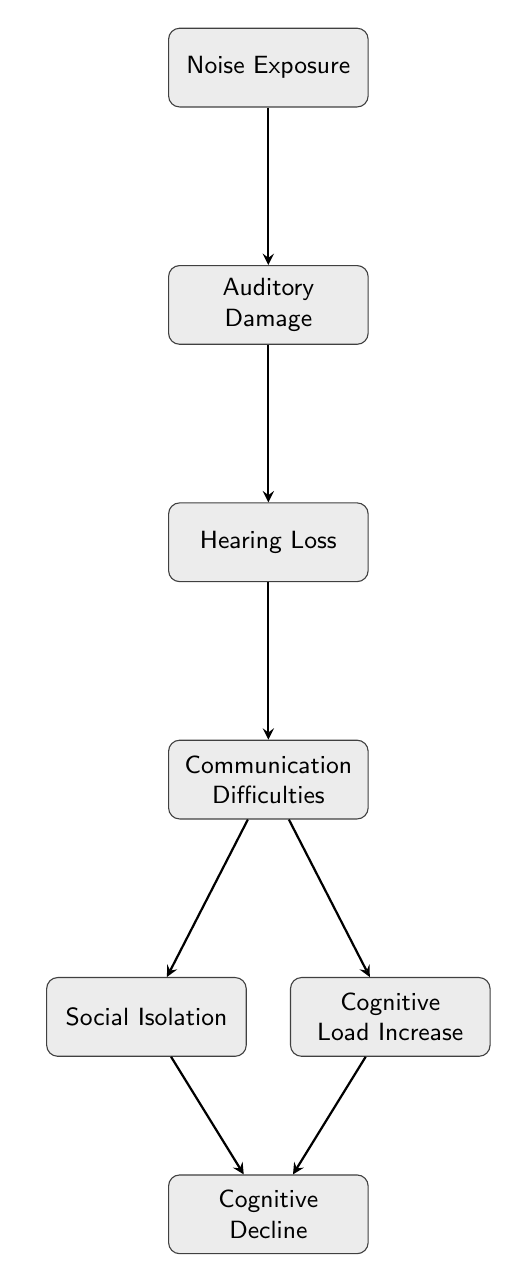What is the first node in the flow chart? The first node is labeled "Noise Exposure," which indicates where the progression begins in the diagram.
Answer: Noise Exposure How many total nodes are in the flow chart? By counting all the labeled blocks in the diagram, there are seven nodes in total.
Answer: 7 What connects "Hearing Loss" to "Communication Difficulties"? "Hearing Loss" leads directly to "Communication Difficulties," as shown by the arrow that indicates the flow from one condition to the next.
Answer: An arrow Name the nodes that contribute to "Cognitive Decline." "Cognitive Decline" is influenced by two nodes: "Social Isolation" and "Cognitive Load Increase," which both feed into it as depicted in the diagram.
Answer: Social Isolation, Cognitive Load Increase What is the relationship between "Communication Difficulties" and "Social Isolation"? "Communication Difficulties" leads to "Social Isolation," indicating that struggles with communication can result in a tendency to avoid social interactions.
Answer: Leads to Why does "Cognitive Load Increase" progress to "Cognitive Decline"? "Cognitive Load Increase" results in a higher mental effort to decode sound, which may overload cognitive resources, ultimately leading to a decline in cognitive function.
Answer: Due to overload What is the consequence of "Auditory Damage"? The direct consequence of "Auditory Damage" is "Hearing Loss," showcasing the immediate impact of damage on hearing capabilities.
Answer: Hearing Loss Which node is affected by "Noise Exposure"? "Noise Exposure" directly affects "Auditory Damage," establishing the initial step in the chain that leads to further complications.
Answer: Auditory Damage 